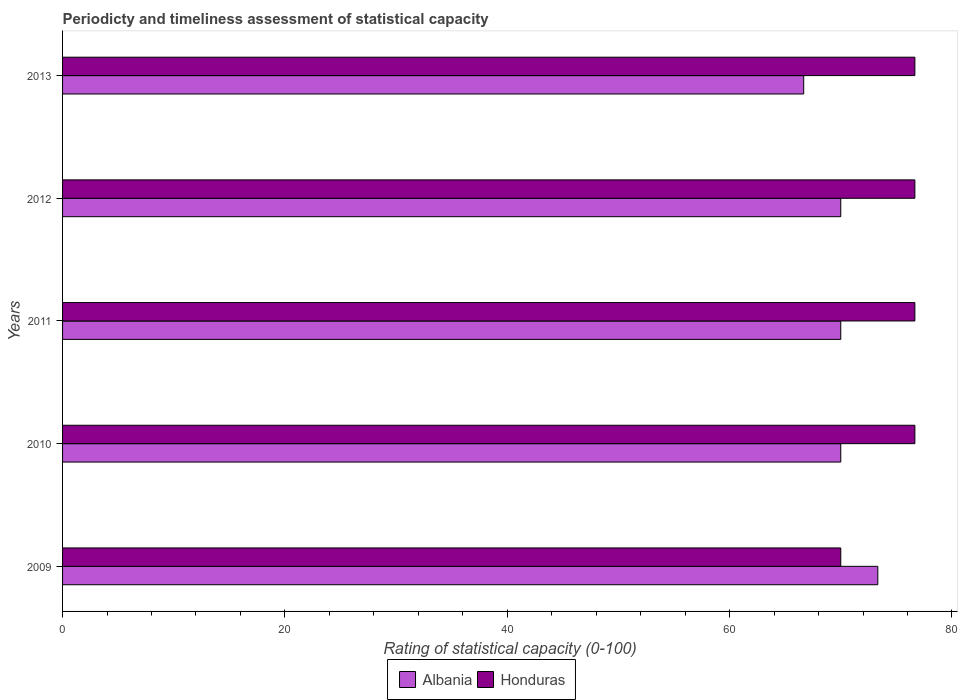How many bars are there on the 2nd tick from the bottom?
Give a very brief answer. 2. What is the label of the 1st group of bars from the top?
Offer a very short reply. 2013. In how many cases, is the number of bars for a given year not equal to the number of legend labels?
Your answer should be compact. 0. Across all years, what is the maximum rating of statistical capacity in Honduras?
Give a very brief answer. 76.67. Across all years, what is the minimum rating of statistical capacity in Honduras?
Keep it short and to the point. 70. In which year was the rating of statistical capacity in Honduras maximum?
Your answer should be compact. 2010. What is the total rating of statistical capacity in Honduras in the graph?
Your response must be concise. 376.67. What is the difference between the rating of statistical capacity in Honduras in 2010 and that in 2013?
Give a very brief answer. 3.3333332964957663e-6. What is the difference between the rating of statistical capacity in Albania in 2011 and the rating of statistical capacity in Honduras in 2012?
Keep it short and to the point. -6.67. What is the average rating of statistical capacity in Honduras per year?
Your response must be concise. 75.33. In the year 2011, what is the difference between the rating of statistical capacity in Albania and rating of statistical capacity in Honduras?
Your answer should be very brief. -6.67. In how many years, is the rating of statistical capacity in Honduras greater than 76 ?
Keep it short and to the point. 4. What is the ratio of the rating of statistical capacity in Albania in 2011 to that in 2013?
Offer a terse response. 1.05. Is the rating of statistical capacity in Albania in 2010 less than that in 2011?
Offer a terse response. No. Is the difference between the rating of statistical capacity in Albania in 2010 and 2012 greater than the difference between the rating of statistical capacity in Honduras in 2010 and 2012?
Your answer should be compact. No. What is the difference between the highest and the lowest rating of statistical capacity in Albania?
Offer a terse response. 6.67. What does the 1st bar from the top in 2009 represents?
Your response must be concise. Honduras. What does the 1st bar from the bottom in 2011 represents?
Your response must be concise. Albania. How many bars are there?
Give a very brief answer. 10. Are all the bars in the graph horizontal?
Ensure brevity in your answer.  Yes. What is the difference between two consecutive major ticks on the X-axis?
Offer a very short reply. 20. Are the values on the major ticks of X-axis written in scientific E-notation?
Your answer should be very brief. No. How are the legend labels stacked?
Provide a short and direct response. Horizontal. What is the title of the graph?
Offer a terse response. Periodicty and timeliness assessment of statistical capacity. Does "Germany" appear as one of the legend labels in the graph?
Make the answer very short. No. What is the label or title of the X-axis?
Your answer should be compact. Rating of statistical capacity (0-100). What is the label or title of the Y-axis?
Provide a short and direct response. Years. What is the Rating of statistical capacity (0-100) of Albania in 2009?
Make the answer very short. 73.33. What is the Rating of statistical capacity (0-100) in Honduras in 2010?
Offer a very short reply. 76.67. What is the Rating of statistical capacity (0-100) of Honduras in 2011?
Give a very brief answer. 76.67. What is the Rating of statistical capacity (0-100) of Albania in 2012?
Offer a terse response. 70. What is the Rating of statistical capacity (0-100) in Honduras in 2012?
Give a very brief answer. 76.67. What is the Rating of statistical capacity (0-100) of Albania in 2013?
Keep it short and to the point. 66.67. What is the Rating of statistical capacity (0-100) of Honduras in 2013?
Make the answer very short. 76.67. Across all years, what is the maximum Rating of statistical capacity (0-100) of Albania?
Give a very brief answer. 73.33. Across all years, what is the maximum Rating of statistical capacity (0-100) of Honduras?
Provide a short and direct response. 76.67. Across all years, what is the minimum Rating of statistical capacity (0-100) of Albania?
Your answer should be very brief. 66.67. What is the total Rating of statistical capacity (0-100) of Albania in the graph?
Ensure brevity in your answer.  350. What is the total Rating of statistical capacity (0-100) in Honduras in the graph?
Keep it short and to the point. 376.67. What is the difference between the Rating of statistical capacity (0-100) in Albania in 2009 and that in 2010?
Make the answer very short. 3.33. What is the difference between the Rating of statistical capacity (0-100) in Honduras in 2009 and that in 2010?
Your response must be concise. -6.67. What is the difference between the Rating of statistical capacity (0-100) of Honduras in 2009 and that in 2011?
Keep it short and to the point. -6.67. What is the difference between the Rating of statistical capacity (0-100) in Honduras in 2009 and that in 2012?
Your answer should be very brief. -6.67. What is the difference between the Rating of statistical capacity (0-100) in Albania in 2009 and that in 2013?
Provide a short and direct response. 6.67. What is the difference between the Rating of statistical capacity (0-100) in Honduras in 2009 and that in 2013?
Offer a terse response. -6.67. What is the difference between the Rating of statistical capacity (0-100) in Albania in 2010 and that in 2011?
Provide a succinct answer. 0. What is the difference between the Rating of statistical capacity (0-100) in Albania in 2010 and that in 2012?
Your answer should be very brief. 0. What is the difference between the Rating of statistical capacity (0-100) in Honduras in 2010 and that in 2012?
Keep it short and to the point. 0. What is the difference between the Rating of statistical capacity (0-100) of Honduras in 2010 and that in 2013?
Your answer should be compact. 0. What is the difference between the Rating of statistical capacity (0-100) of Albania in 2011 and that in 2012?
Offer a terse response. 0. What is the difference between the Rating of statistical capacity (0-100) of Honduras in 2011 and that in 2013?
Keep it short and to the point. 0. What is the difference between the Rating of statistical capacity (0-100) in Albania in 2012 and that in 2013?
Make the answer very short. 3.33. What is the difference between the Rating of statistical capacity (0-100) of Honduras in 2012 and that in 2013?
Provide a short and direct response. 0. What is the difference between the Rating of statistical capacity (0-100) of Albania in 2009 and the Rating of statistical capacity (0-100) of Honduras in 2010?
Your answer should be very brief. -3.33. What is the difference between the Rating of statistical capacity (0-100) of Albania in 2009 and the Rating of statistical capacity (0-100) of Honduras in 2011?
Your answer should be compact. -3.33. What is the difference between the Rating of statistical capacity (0-100) of Albania in 2009 and the Rating of statistical capacity (0-100) of Honduras in 2012?
Ensure brevity in your answer.  -3.33. What is the difference between the Rating of statistical capacity (0-100) of Albania in 2009 and the Rating of statistical capacity (0-100) of Honduras in 2013?
Give a very brief answer. -3.33. What is the difference between the Rating of statistical capacity (0-100) of Albania in 2010 and the Rating of statistical capacity (0-100) of Honduras in 2011?
Keep it short and to the point. -6.67. What is the difference between the Rating of statistical capacity (0-100) of Albania in 2010 and the Rating of statistical capacity (0-100) of Honduras in 2012?
Ensure brevity in your answer.  -6.67. What is the difference between the Rating of statistical capacity (0-100) of Albania in 2010 and the Rating of statistical capacity (0-100) of Honduras in 2013?
Ensure brevity in your answer.  -6.67. What is the difference between the Rating of statistical capacity (0-100) of Albania in 2011 and the Rating of statistical capacity (0-100) of Honduras in 2012?
Your answer should be very brief. -6.67. What is the difference between the Rating of statistical capacity (0-100) of Albania in 2011 and the Rating of statistical capacity (0-100) of Honduras in 2013?
Offer a very short reply. -6.67. What is the difference between the Rating of statistical capacity (0-100) of Albania in 2012 and the Rating of statistical capacity (0-100) of Honduras in 2013?
Provide a short and direct response. -6.67. What is the average Rating of statistical capacity (0-100) of Albania per year?
Your answer should be compact. 70. What is the average Rating of statistical capacity (0-100) of Honduras per year?
Provide a short and direct response. 75.33. In the year 2009, what is the difference between the Rating of statistical capacity (0-100) of Albania and Rating of statistical capacity (0-100) of Honduras?
Make the answer very short. 3.33. In the year 2010, what is the difference between the Rating of statistical capacity (0-100) in Albania and Rating of statistical capacity (0-100) in Honduras?
Offer a terse response. -6.67. In the year 2011, what is the difference between the Rating of statistical capacity (0-100) of Albania and Rating of statistical capacity (0-100) of Honduras?
Your response must be concise. -6.67. In the year 2012, what is the difference between the Rating of statistical capacity (0-100) in Albania and Rating of statistical capacity (0-100) in Honduras?
Keep it short and to the point. -6.67. In the year 2013, what is the difference between the Rating of statistical capacity (0-100) in Albania and Rating of statistical capacity (0-100) in Honduras?
Offer a terse response. -10. What is the ratio of the Rating of statistical capacity (0-100) in Albania in 2009 to that in 2010?
Your answer should be compact. 1.05. What is the ratio of the Rating of statistical capacity (0-100) of Albania in 2009 to that in 2011?
Ensure brevity in your answer.  1.05. What is the ratio of the Rating of statistical capacity (0-100) in Honduras in 2009 to that in 2011?
Your response must be concise. 0.91. What is the ratio of the Rating of statistical capacity (0-100) in Albania in 2009 to that in 2012?
Provide a succinct answer. 1.05. What is the ratio of the Rating of statistical capacity (0-100) of Honduras in 2009 to that in 2013?
Your answer should be compact. 0.91. What is the ratio of the Rating of statistical capacity (0-100) in Honduras in 2010 to that in 2011?
Offer a very short reply. 1. What is the ratio of the Rating of statistical capacity (0-100) in Albania in 2010 to that in 2012?
Your answer should be compact. 1. What is the ratio of the Rating of statistical capacity (0-100) of Albania in 2011 to that in 2012?
Give a very brief answer. 1. What is the ratio of the Rating of statistical capacity (0-100) in Honduras in 2011 to that in 2012?
Your response must be concise. 1. What is the ratio of the Rating of statistical capacity (0-100) in Honduras in 2011 to that in 2013?
Offer a very short reply. 1. What is the ratio of the Rating of statistical capacity (0-100) of Albania in 2012 to that in 2013?
Make the answer very short. 1.05. What is the difference between the highest and the second highest Rating of statistical capacity (0-100) of Albania?
Offer a terse response. 3.33. What is the difference between the highest and the lowest Rating of statistical capacity (0-100) in Honduras?
Your answer should be very brief. 6.67. 